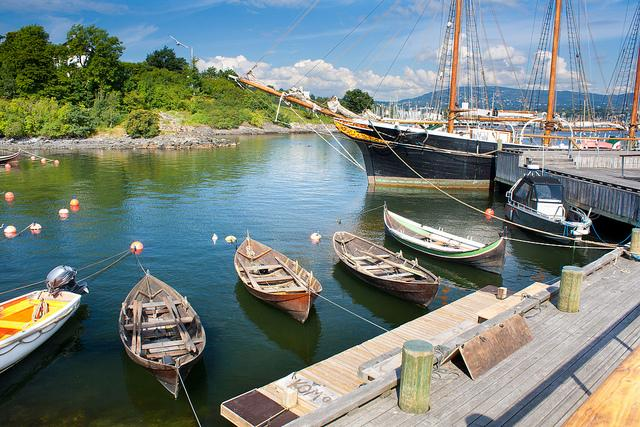What is the color of the sail boat? Please explain your reasoning. black. The main color is not red white or orange. 